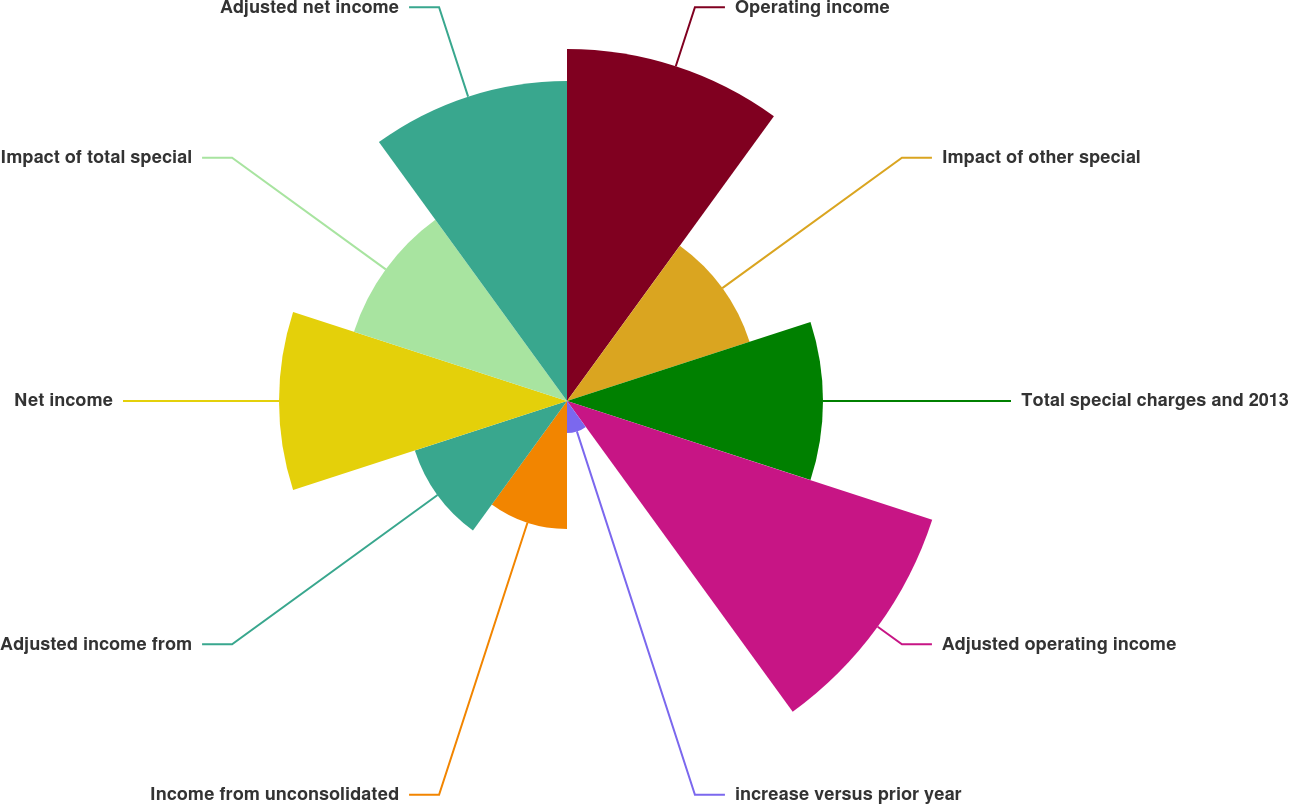<chart> <loc_0><loc_0><loc_500><loc_500><pie_chart><fcel>Operating income<fcel>Impact of other special<fcel>Total special charges and 2013<fcel>Adjusted operating income<fcel>increase versus prior year<fcel>Income from unconsolidated<fcel>Adjusted income from<fcel>Net income<fcel>Impact of total special<fcel>Adjusted net income<nl><fcel>15.07%<fcel>8.22%<fcel>10.96%<fcel>16.44%<fcel>1.37%<fcel>5.48%<fcel>6.85%<fcel>12.33%<fcel>9.59%<fcel>13.7%<nl></chart> 